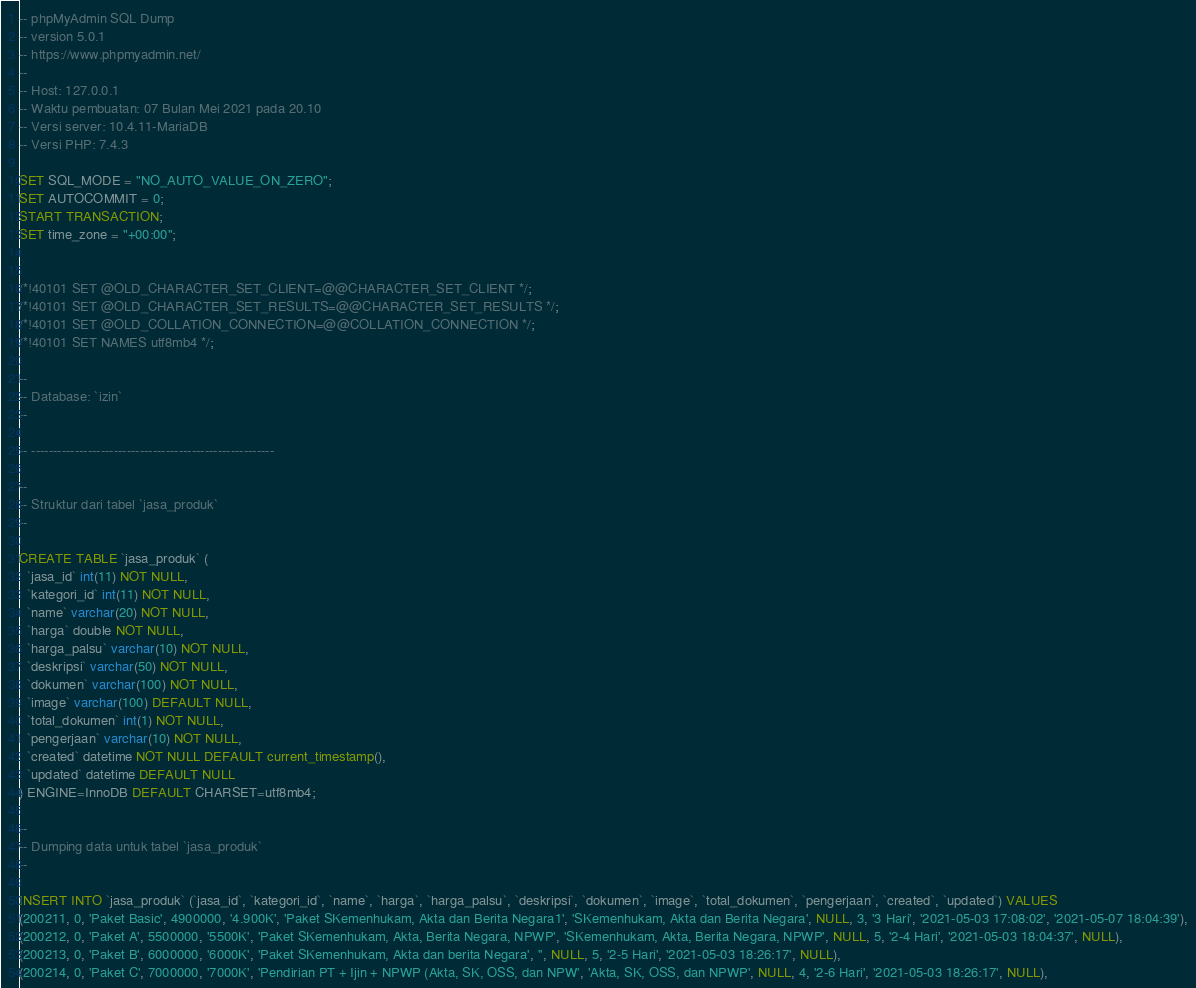<code> <loc_0><loc_0><loc_500><loc_500><_SQL_>-- phpMyAdmin SQL Dump
-- version 5.0.1
-- https://www.phpmyadmin.net/
--
-- Host: 127.0.0.1
-- Waktu pembuatan: 07 Bulan Mei 2021 pada 20.10
-- Versi server: 10.4.11-MariaDB
-- Versi PHP: 7.4.3

SET SQL_MODE = "NO_AUTO_VALUE_ON_ZERO";
SET AUTOCOMMIT = 0;
START TRANSACTION;
SET time_zone = "+00:00";


/*!40101 SET @OLD_CHARACTER_SET_CLIENT=@@CHARACTER_SET_CLIENT */;
/*!40101 SET @OLD_CHARACTER_SET_RESULTS=@@CHARACTER_SET_RESULTS */;
/*!40101 SET @OLD_COLLATION_CONNECTION=@@COLLATION_CONNECTION */;
/*!40101 SET NAMES utf8mb4 */;

--
-- Database: `izin`
--

-- --------------------------------------------------------

--
-- Struktur dari tabel `jasa_produk`
--

CREATE TABLE `jasa_produk` (
  `jasa_id` int(11) NOT NULL,
  `kategori_id` int(11) NOT NULL,
  `name` varchar(20) NOT NULL,
  `harga` double NOT NULL,
  `harga_palsu` varchar(10) NOT NULL,
  `deskripsi` varchar(50) NOT NULL,
  `dokumen` varchar(100) NOT NULL,
  `image` varchar(100) DEFAULT NULL,
  `total_dokumen` int(1) NOT NULL,
  `pengerjaan` varchar(10) NOT NULL,
  `created` datetime NOT NULL DEFAULT current_timestamp(),
  `updated` datetime DEFAULT NULL
) ENGINE=InnoDB DEFAULT CHARSET=utf8mb4;

--
-- Dumping data untuk tabel `jasa_produk`
--

INSERT INTO `jasa_produk` (`jasa_id`, `kategori_id`, `name`, `harga`, `harga_palsu`, `deskripsi`, `dokumen`, `image`, `total_dokumen`, `pengerjaan`, `created`, `updated`) VALUES
(200211, 0, 'Paket Basic', 4900000, '4.900K', 'Paket SKemenhukam, Akta dan Berita Negara1', 'SKemenhukam, Akta dan Berita Negara', NULL, 3, '3 Hari', '2021-05-03 17:08:02', '2021-05-07 18:04:39'),
(200212, 0, 'Paket A', 5500000, '5500K', 'Paket SKemenhukam, Akta, Berita Negara, NPWP', 'SKemenhukam, Akta, Berita Negara, NPWP', NULL, 5, '2-4 Hari', '2021-05-03 18:04:37', NULL),
(200213, 0, 'Paket B', 6000000, '6000K', 'Paket SKemenhukam, Akta dan berita Negara', '', NULL, 5, '2-5 Hari', '2021-05-03 18:26:17', NULL),
(200214, 0, 'Paket C', 7000000, '7000K', 'Pendirian PT + Ijin + NPWP (Akta, SK, OSS, dan NPW', 'Akta, SK, OSS, dan NPWP', NULL, 4, '2-6 Hari', '2021-05-03 18:26:17', NULL),</code> 